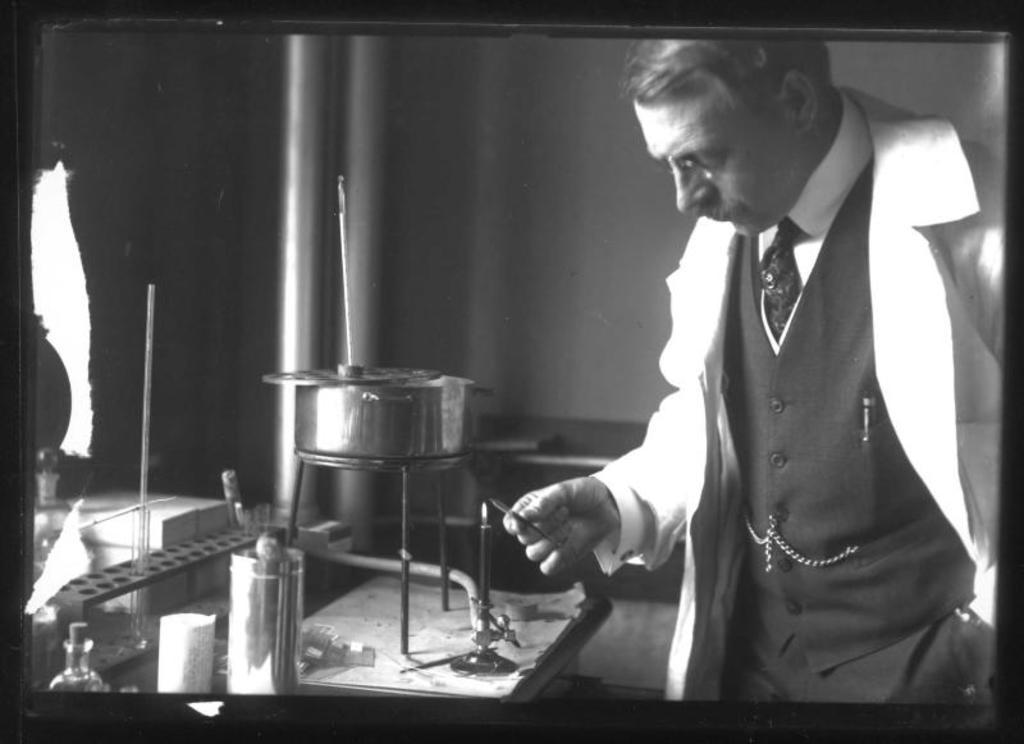What is the main subject of the image? There is a person standing in the image. What can be seen in the person's hands? There are utensils in the image. What is the person standing next to? There is a stand in the image. Can you describe the overall appearance of the image? The image is in black and white. What other objects are present in the image? There are other objects in the image. How many feet are visible in the image? The image is in black and white and only shows a person standing, so it is impossible to determine the number of feet visible. What nation is represented by the flag in the image? There is no flag present in the image. 